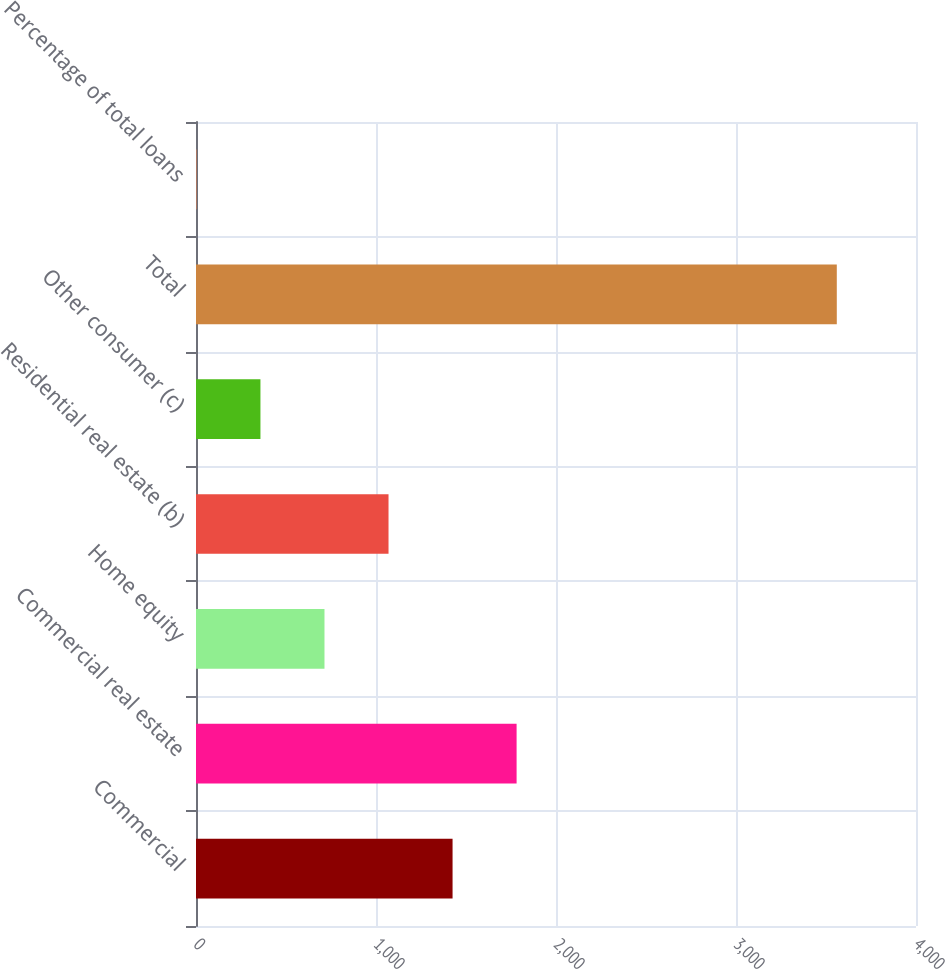<chart> <loc_0><loc_0><loc_500><loc_500><bar_chart><fcel>Commercial<fcel>Commercial real estate<fcel>Home equity<fcel>Residential real estate (b)<fcel>Other consumer (c)<fcel>Total<fcel>Percentage of total loans<nl><fcel>1425.36<fcel>1781.14<fcel>713.8<fcel>1069.58<fcel>358.02<fcel>3560<fcel>2.24<nl></chart> 